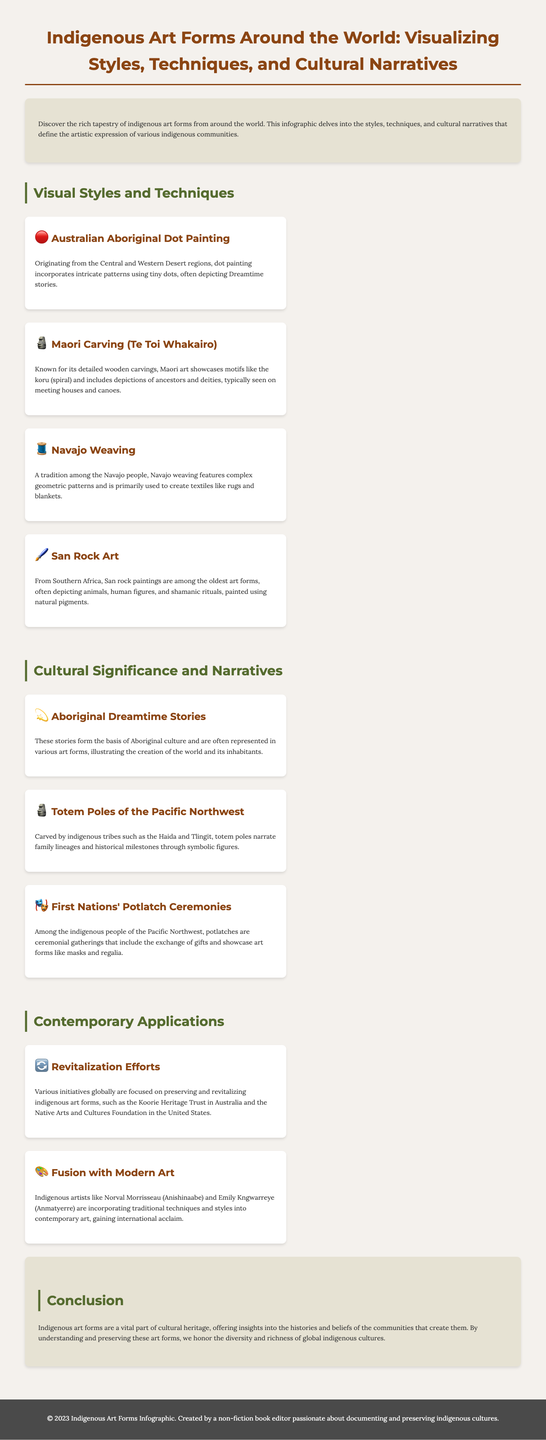what is the title of the infographic? The title of the infographic is prominently displayed at the top of the document.
Answer: Indigenous Art Forms Around the World: Visualizing Styles, Techniques, and Cultural Narratives what technique is used in Australian Aboriginal art? The document mentions a specific technique associated with Australian Aboriginal art.
Answer: Dot Painting which indigenous community is associated with the koru motif? The koru motif is specifically highlighted as part of the art forms of a particular indigenous community.
Answer: Maori how many contemporary applications are discussed in the infographic? The infographic lists two distinct contemporary applications relevant to indigenous art.
Answer: 2 what do potlatch ceremonies showcase? The document describes the significance of potlatch ceremonies within a specific indigenous culture.
Answer: Art forms like masks and regalia which initiative is mentioned for revitalizing indigenous art forms in Australia? The document refers to a specific initiative aimed at preserving indigenous art in Australia.
Answer: Koorie Heritage Trust what is the cultural significance of totem poles? The role of totem poles in indigenous culture is explained in the infographic.
Answer: Narrate family lineages and historical milestones who is an artist noted for incorporating traditional techniques into contemporary art? The document lists a notable indigenous artist who blends traditional art with modern techniques.
Answer: Norval Morrisseau 